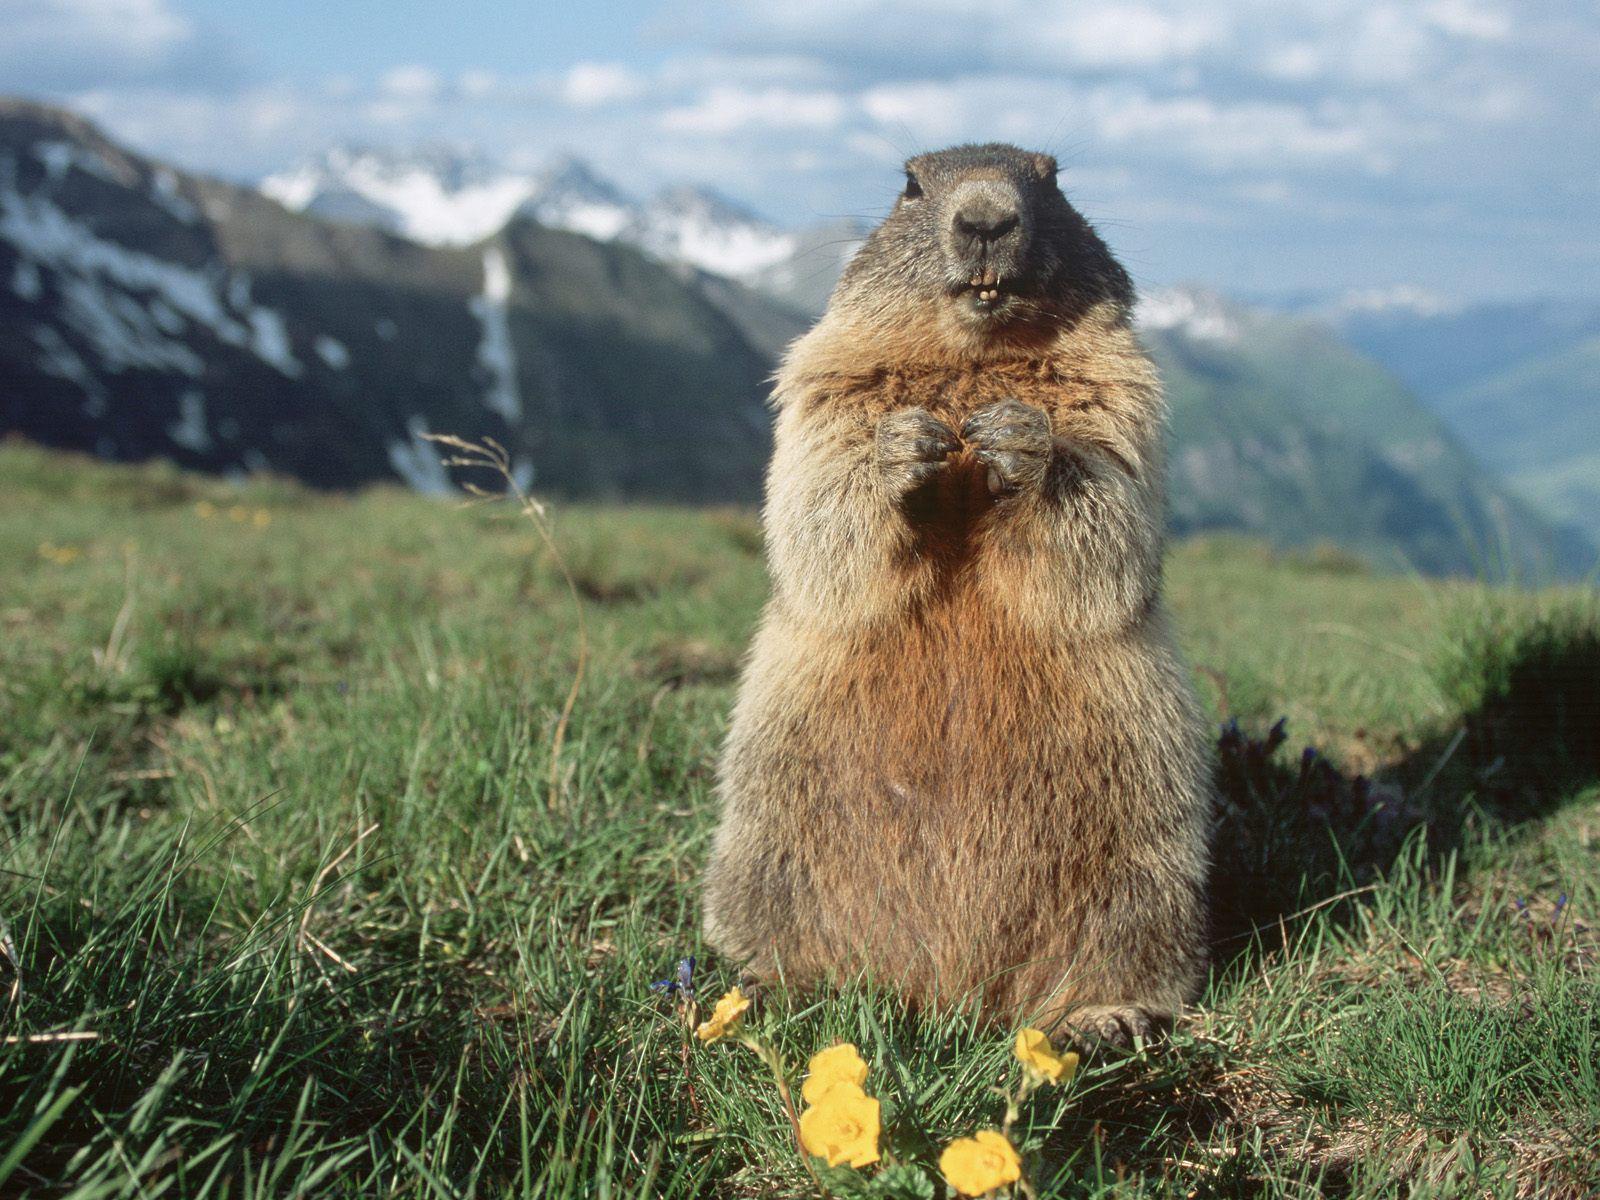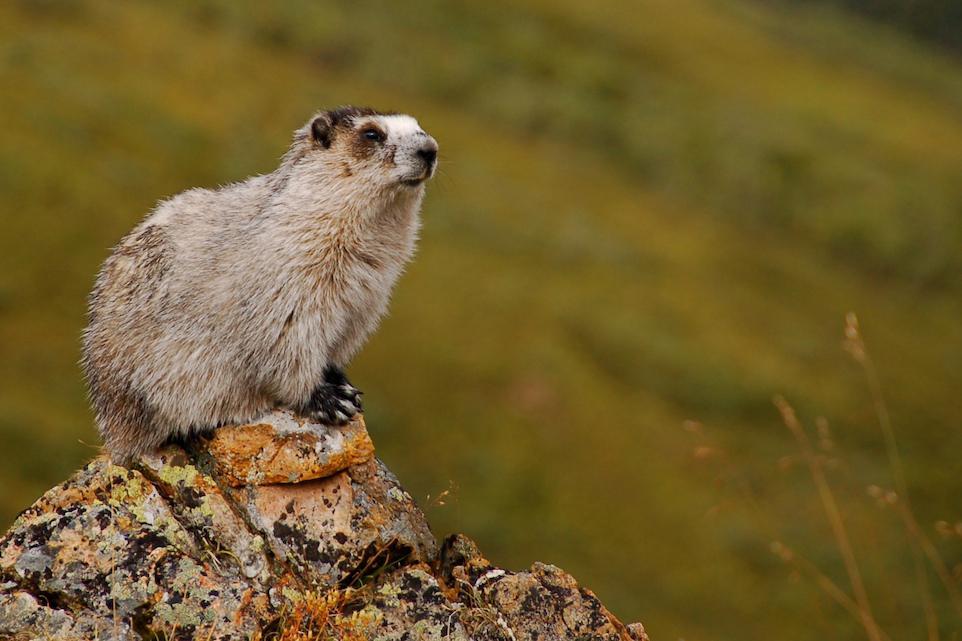The first image is the image on the left, the second image is the image on the right. Assess this claim about the two images: "The marmot in the left image is looking in the direction of the camera". Correct or not? Answer yes or no. Yes. The first image is the image on the left, the second image is the image on the right. For the images shown, is this caption "The animals in the image on the left are on a rocky peak." true? Answer yes or no. No. 